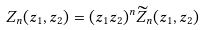<formula> <loc_0><loc_0><loc_500><loc_500>Z _ { n } ( z _ { 1 } , z _ { 2 } ) = ( z _ { 1 } z _ { 2 } ) ^ { n } \widetilde { Z } _ { n } ( z _ { 1 } , z _ { 2 } )</formula> 